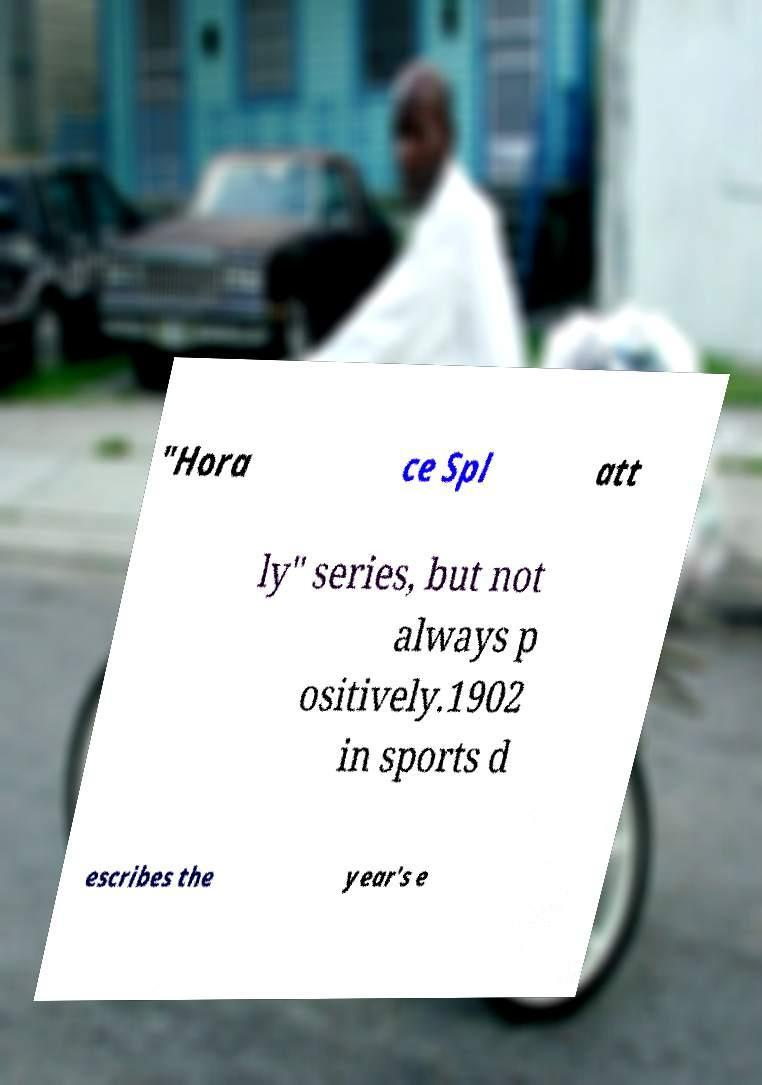Can you accurately transcribe the text from the provided image for me? "Hora ce Spl att ly" series, but not always p ositively.1902 in sports d escribes the year's e 